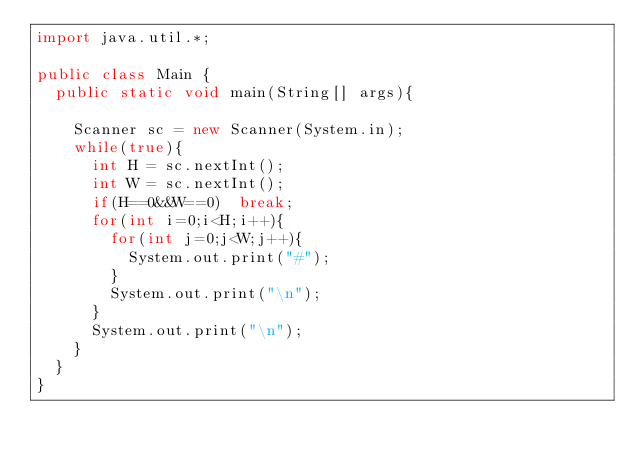<code> <loc_0><loc_0><loc_500><loc_500><_Java_>import java.util.*;

public class Main {
  public static void main(String[] args){

    Scanner sc = new Scanner(System.in);
    while(true){
      int H = sc.nextInt();
      int W = sc.nextInt();
      if(H==0&&W==0)  break;
      for(int i=0;i<H;i++){
        for(int j=0;j<W;j++){
          System.out.print("#");
        }
        System.out.print("\n");
      }
      System.out.print("\n");
    }
  }
}

</code> 